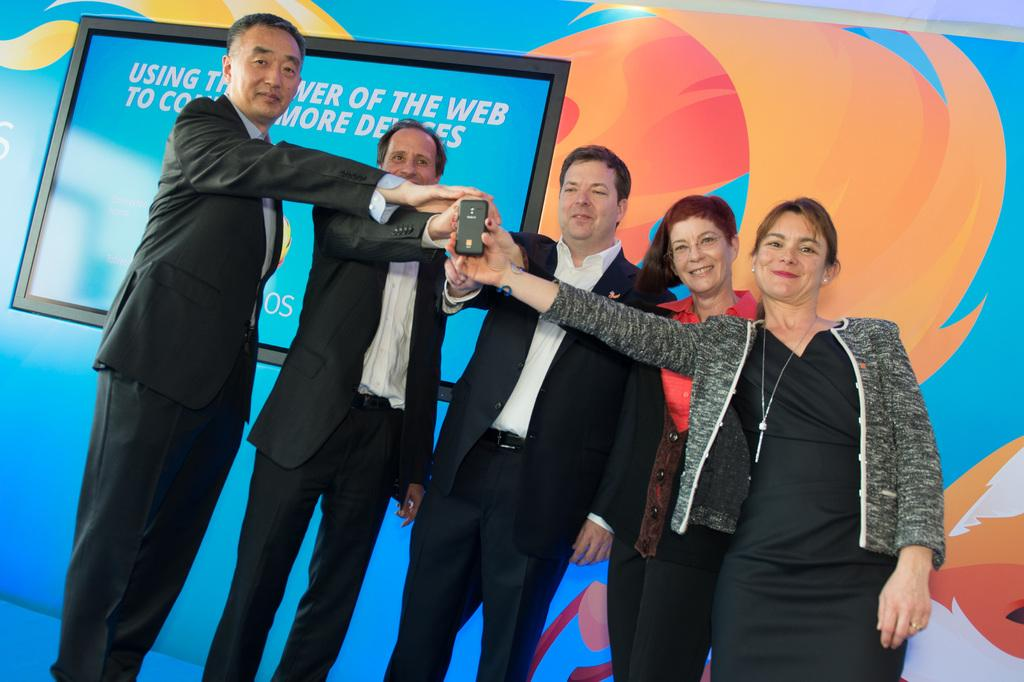How many people are in the image? There is a group of people in the image, but the exact number is not specified. What is the facial expression of the people in the image? The people in the image are smiling. What are the people holding in their hands? The people are holding a mobile phone in their hands. What can be seen in the background of the image? There is a hoarding in the background of the image. What type of engine is being produced by the people in the image? There is no engine present in the image, nor are the people producing anything. 